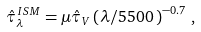Convert formula to latex. <formula><loc_0><loc_0><loc_500><loc_500>\hat { \tau } _ { \lambda } ^ { \, I S M } = \mu \hat { \tau } _ { V } \left ( \lambda / { 5 5 0 0 \, \AA } \right ) ^ { - 0 . 7 } \, ,</formula> 